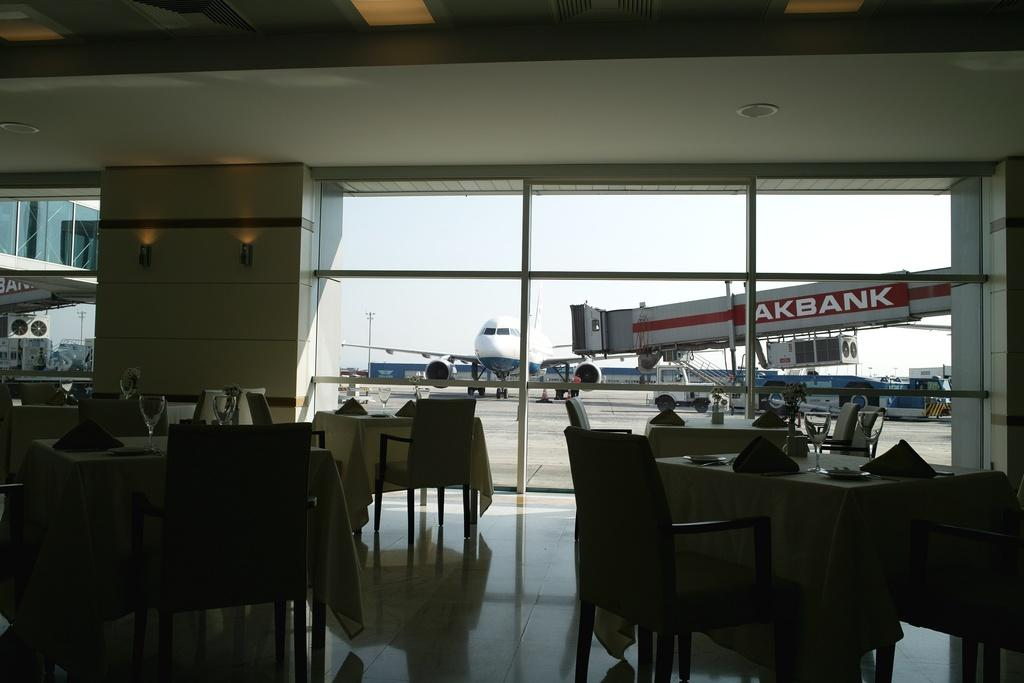What type of location is depicted in the image? The image appears to depict a restaurant setting. Can you describe the seating arrangement in the image? There are multiple empty tables and chairs in the image. What can be seen through the windows in the image? Aircrafts are visible through the windows. Can you tell me the color of the flower on the table in the image? There is no flower present on the table in the image. What is your uncle doing in the image? There is no person, let alone an uncle, present in the image. 